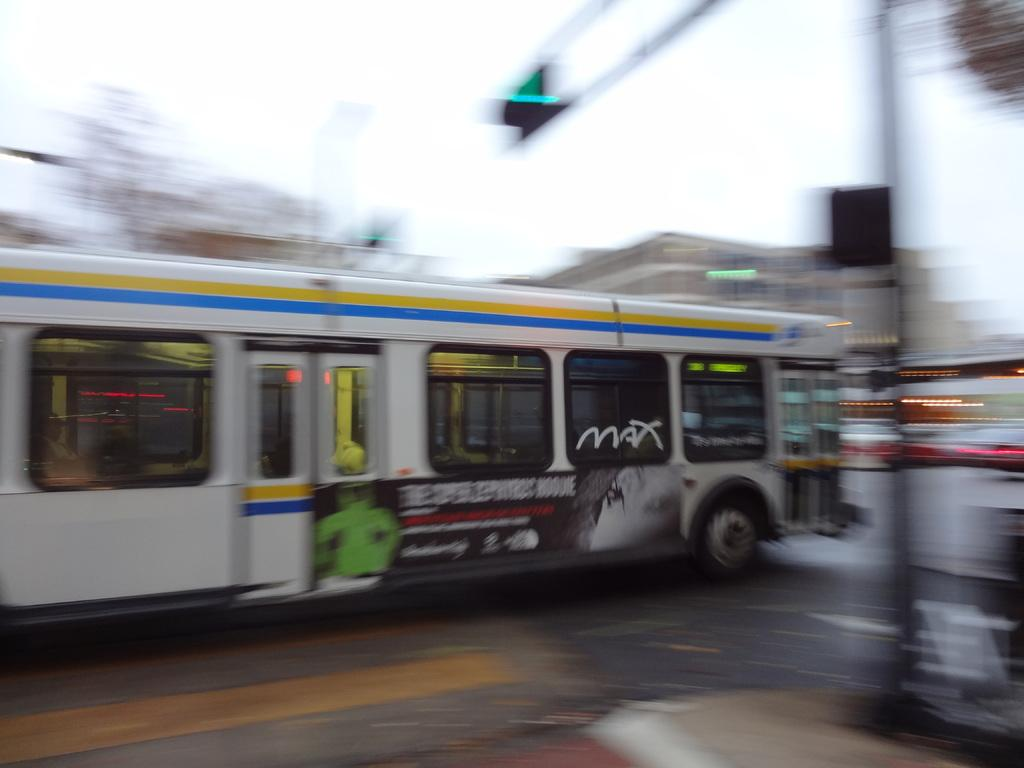What is the main subject of the image? The main subject of the image is a bus. What else can be seen in the image besides the bus? There is a signal light in the image. What is visible in the background of the image? The sky is visible in the image. What type of property is being tested in the image? There is no property or testing activity present in the image; it features a bus and a signal light. 